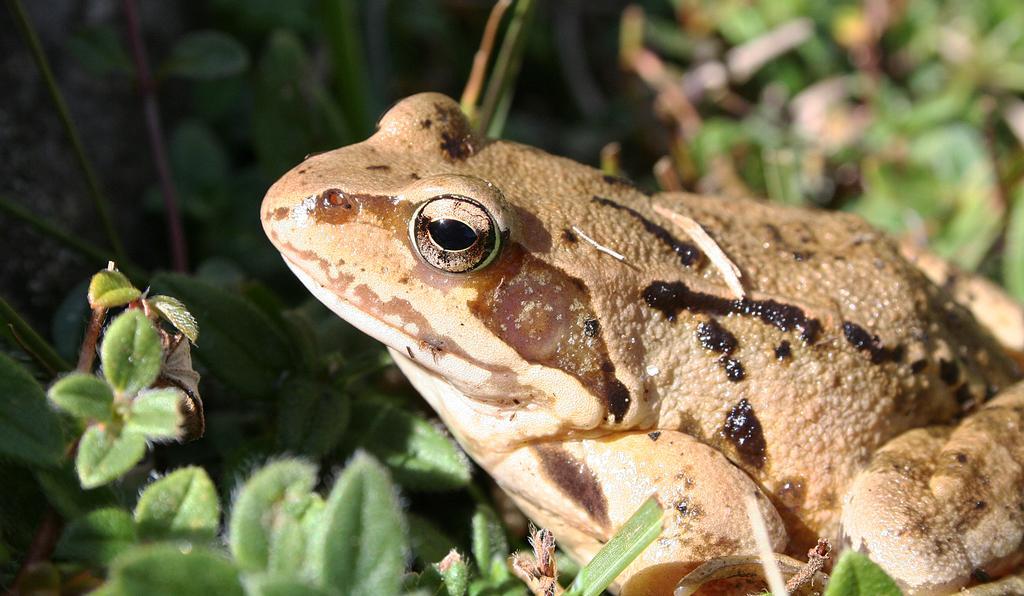In one or two sentences, can you explain what this image depicts? In this picture there is a frog who is sitting near to the plants. At the bottom we can see the leaves. 